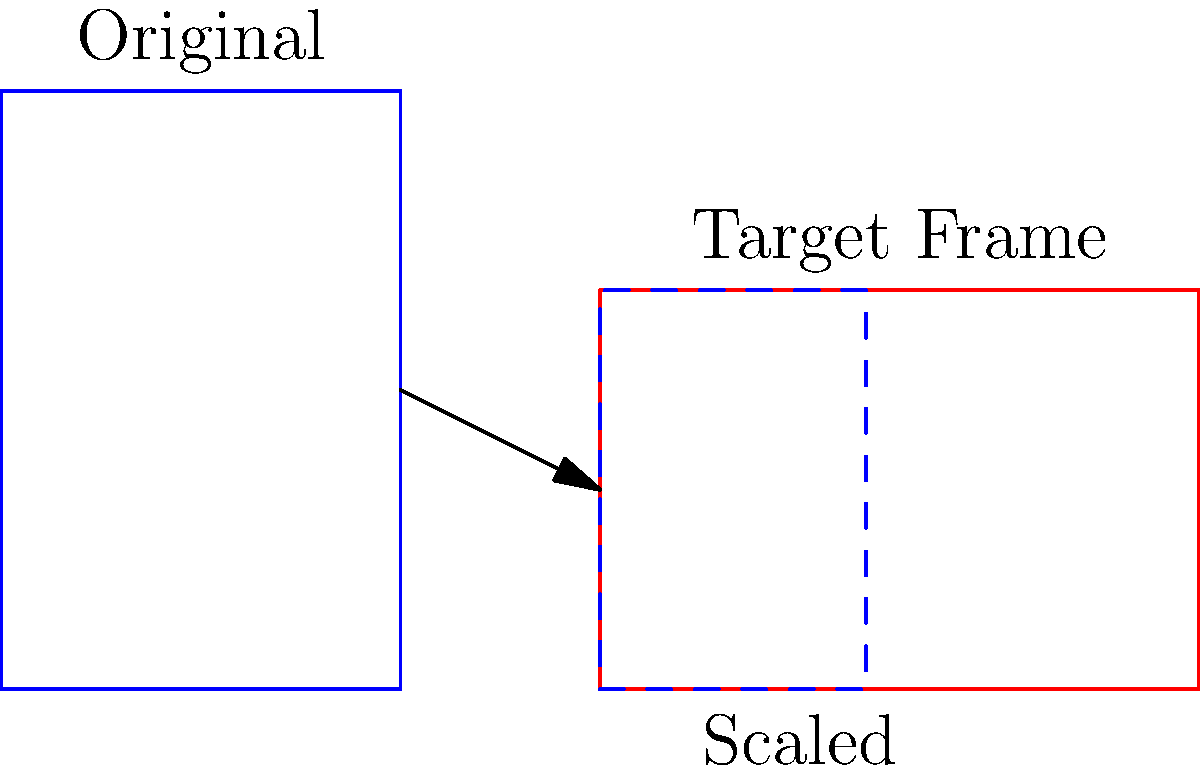A rectangular coat of arms design measures 4 units wide and 6 units tall. You need to scale this design to fit within a rectangular frame that is 6 units wide and 4 units tall, maintaining its original proportions. What is the scale factor you should apply to the original design? To solve this problem, we need to follow these steps:

1. Identify the original dimensions:
   Width = 4 units, Height = 6 units

2. Identify the target frame dimensions:
   Width = 6 units, Height = 4 units

3. Calculate the scale factors for both width and height:
   Width scale factor: $6 / 4 = 1.5$
   Height scale factor: $4 / 6 = 0.6667$

4. Choose the smaller scale factor to ensure the design fits within the frame while maintaining its proportions:
   Scale factor = $\min(1.5, 0.6667) = 0.6667$

5. Verify the result:
   New width: $4 * 0.6667 = 2.6667$ units (fits within 6 units)
   New height: $6 * 0.6667 = 4$ units (exactly fits 4 units)

Therefore, the scale factor that should be applied to the original design is 0.6667 (or 2/3).
Answer: $\frac{2}{3}$ or 0.6667 